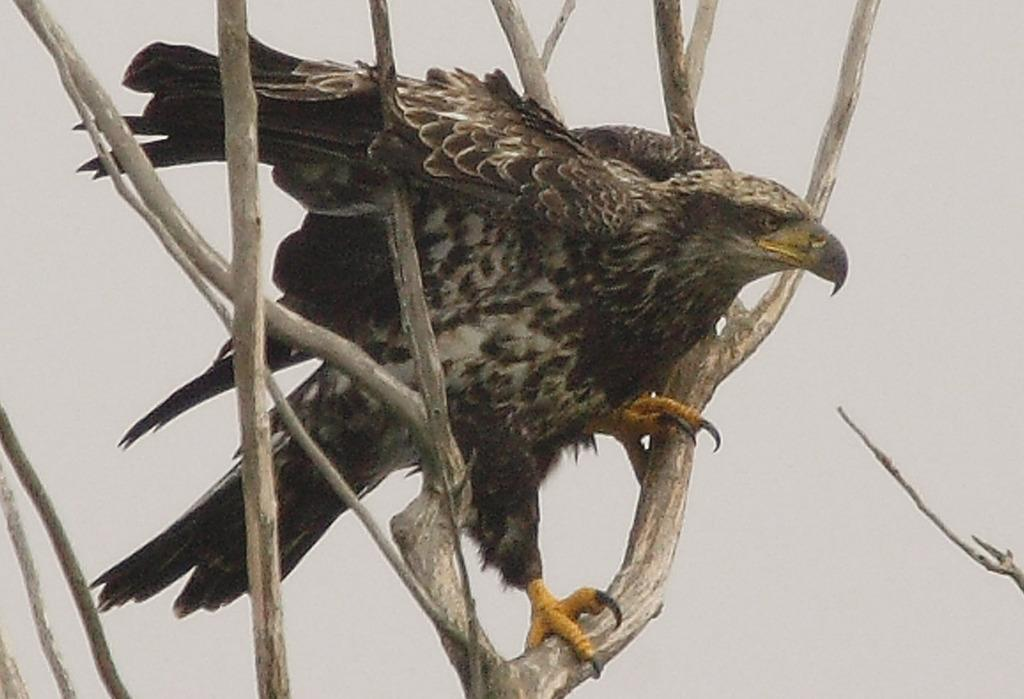What animal is featured in the image? There is an eagle in the image. Where is the eagle located? The eagle is on the branches of a tree. What is the condition of the sky in the image? The sky is cloudy. What type of vest is the eagle wearing in the image? There is no vest present in the image, as eagles do not wear clothing. How many quarters can be seen on the branches of the tree in the image? There are no quarters present in the image; it features an eagle on the branches of a tree. 